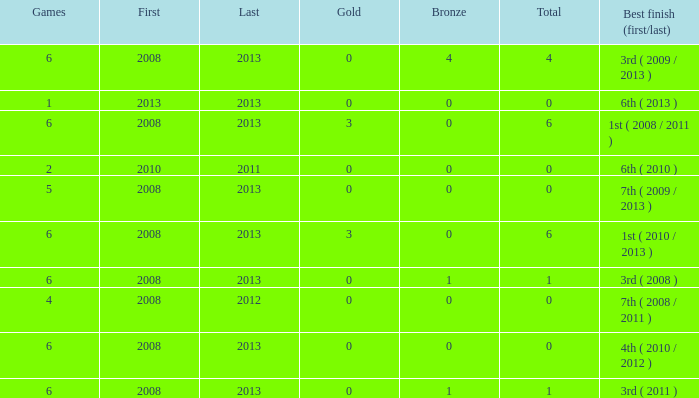How many bronzes associated with over 0 total medals, 3 golds, and over 6 games? None. 